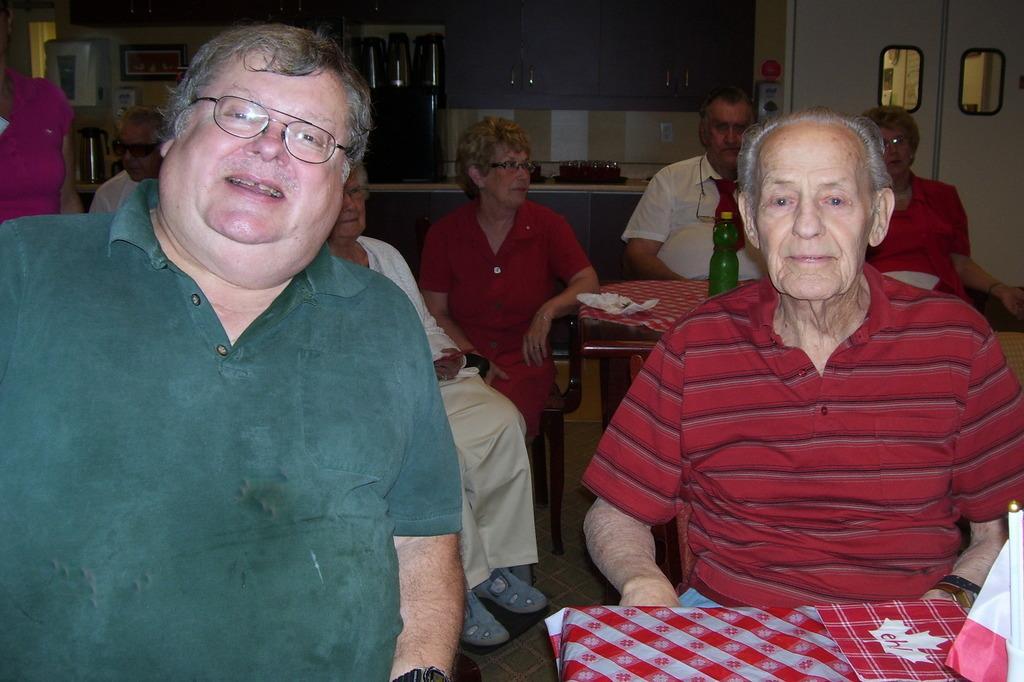In one or two sentences, can you explain what this image depicts? In the front there are two men sitting. Into the left there men with green color t-shirt. To the right side there is man with red color t-shirt. In front of him there is a object with red color and white color. Behind them are some people sitting. And in front of them there is a table. On the table we can see a green bottle. On the top right corner there is a door. In the background there are cupboards,jugs. 